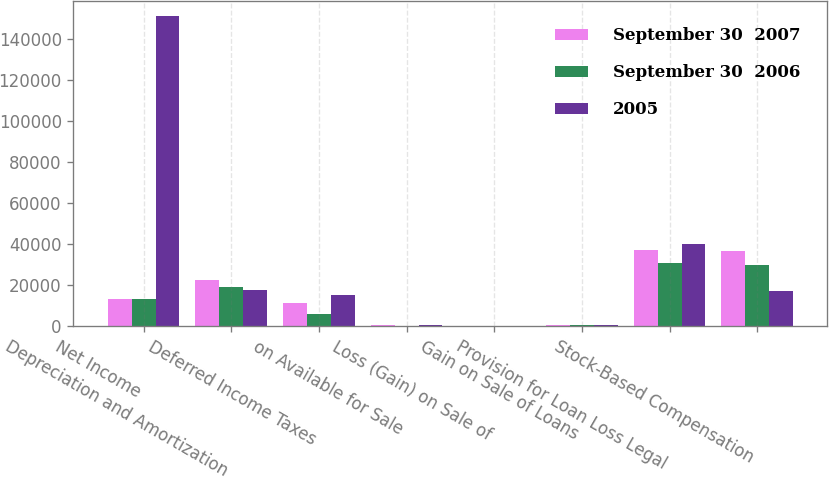Convert chart. <chart><loc_0><loc_0><loc_500><loc_500><stacked_bar_chart><ecel><fcel>Net Income<fcel>Depreciation and Amortization<fcel>Deferred Income Taxes<fcel>on Available for Sale<fcel>Loss (Gain) on Sale of<fcel>Gain on Sale of Loans<fcel>Provision for Loan Loss Legal<fcel>Stock-Based Compensation<nl><fcel>September 30  2007<fcel>13408<fcel>22631<fcel>11515<fcel>790<fcel>20<fcel>518<fcel>37138<fcel>36563<nl><fcel>September 30  2006<fcel>13408<fcel>19173<fcel>6097<fcel>196<fcel>143<fcel>413<fcel>31011<fcel>29820<nl><fcel>2005<fcel>151046<fcel>17781<fcel>15301<fcel>794<fcel>106<fcel>421<fcel>39854<fcel>17031<nl></chart> 